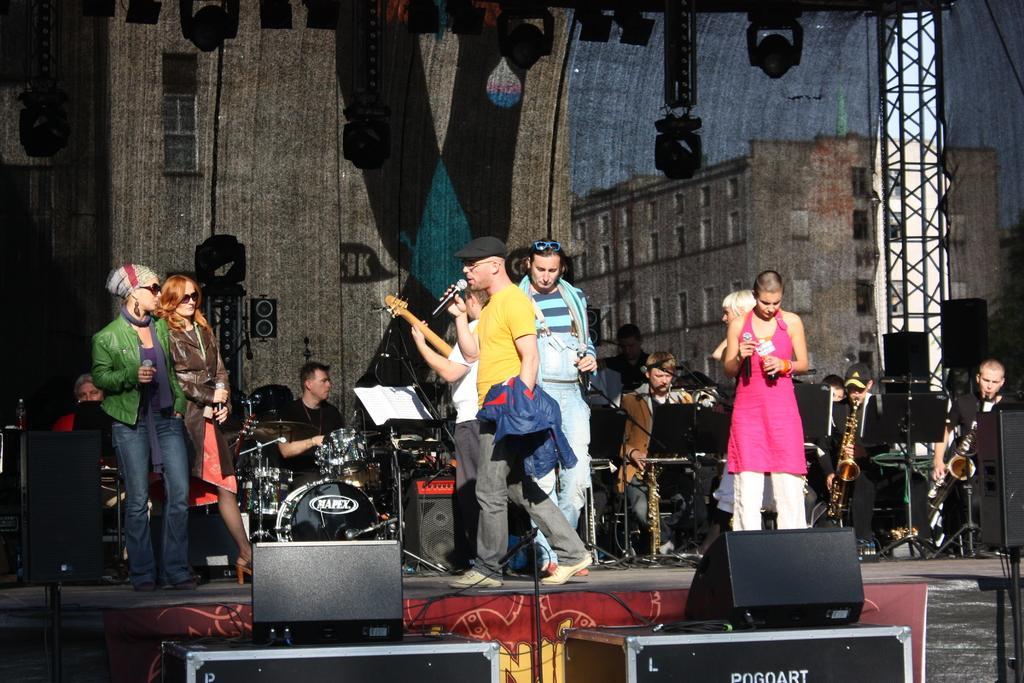Describe this image in one or two sentences. This picture is clicked in a musical concert. Man in yellow t-shirt is holding microphone in his hand and singing on it. Beside him, man in white t-shirt is holding guitar and playing it and behind them, we see man in black shirt is playing guitar and on the right corner of the picture, we see two men playing saxophone. Woman in pink shirt is holding microphone in her hand. 